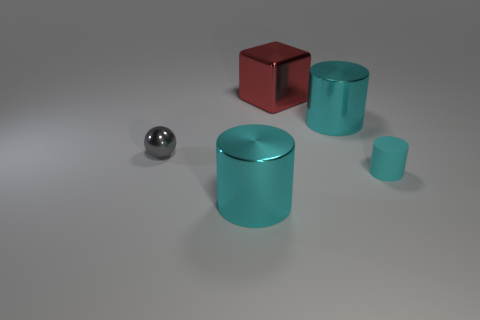How might the different textures of these objects affect their use in a practical setting? The smooth, shiny surfaces of the metallic objects suggest that they are easily cleanable and might find use in sterile environments. However, such surfaces can also show fingerprints and smudges more clearly, requiring frequent cleaning. They might be suitable for decorative elements or functional parts in machinery that value aesthetics and clean lines. 